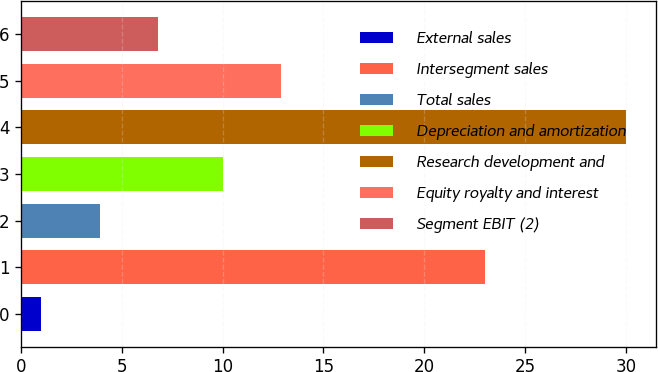Convert chart to OTSL. <chart><loc_0><loc_0><loc_500><loc_500><bar_chart><fcel>External sales<fcel>Intersegment sales<fcel>Total sales<fcel>Depreciation and amortization<fcel>Research development and<fcel>Equity royalty and interest<fcel>Segment EBIT (2)<nl><fcel>1<fcel>23<fcel>3.9<fcel>10<fcel>30<fcel>12.9<fcel>6.8<nl></chart> 